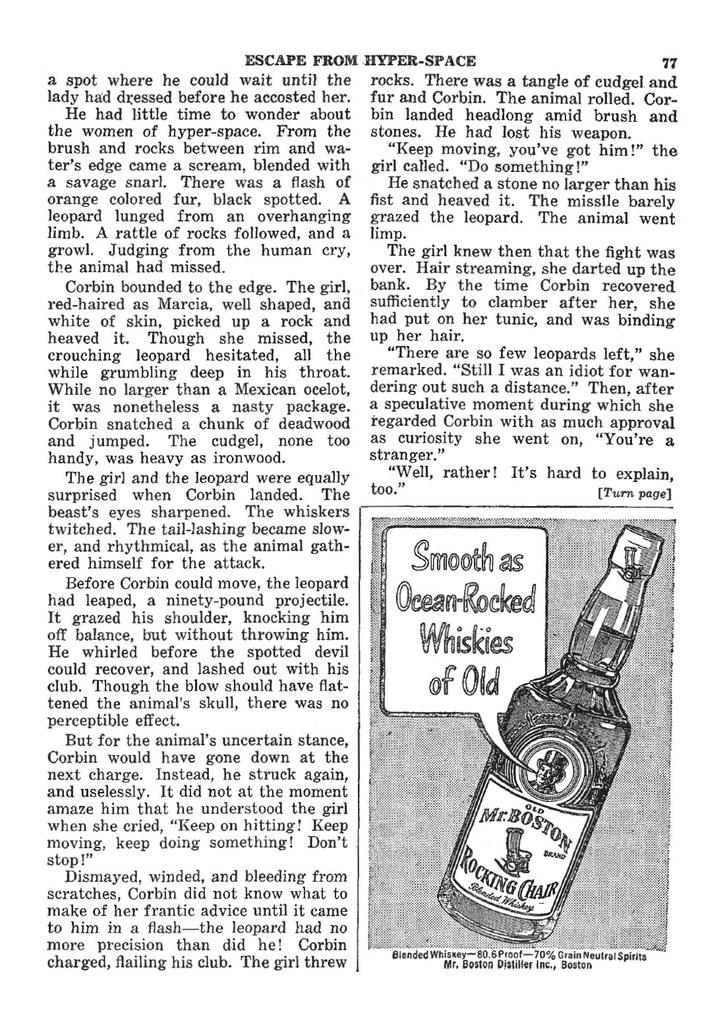<image>
Give a short and clear explanation of the subsequent image. A printed page numbered 77 is shown with a picture of a bottle in the corner. 